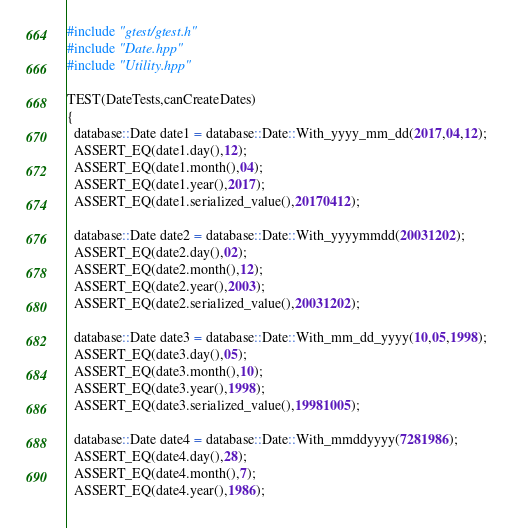Convert code to text. <code><loc_0><loc_0><loc_500><loc_500><_C++_>#include "gtest/gtest.h"
#include "Date.hpp"
#include "Utility.hpp"

TEST(DateTests,canCreateDates)
{
  database::Date date1 = database::Date::With_yyyy_mm_dd(2017,04,12);
  ASSERT_EQ(date1.day(),12);
  ASSERT_EQ(date1.month(),04);
  ASSERT_EQ(date1.year(),2017);
  ASSERT_EQ(date1.serialized_value(),20170412);

  database::Date date2 = database::Date::With_yyyymmdd(20031202);
  ASSERT_EQ(date2.day(),02);
  ASSERT_EQ(date2.month(),12);
  ASSERT_EQ(date2.year(),2003);
  ASSERT_EQ(date2.serialized_value(),20031202);

  database::Date date3 = database::Date::With_mm_dd_yyyy(10,05,1998);
  ASSERT_EQ(date3.day(),05);
  ASSERT_EQ(date3.month(),10);
  ASSERT_EQ(date3.year(),1998);
  ASSERT_EQ(date3.serialized_value(),19981005);

  database::Date date4 = database::Date::With_mmddyyyy(7281986);
  ASSERT_EQ(date4.day(),28);
  ASSERT_EQ(date4.month(),7);
  ASSERT_EQ(date4.year(),1986);</code> 